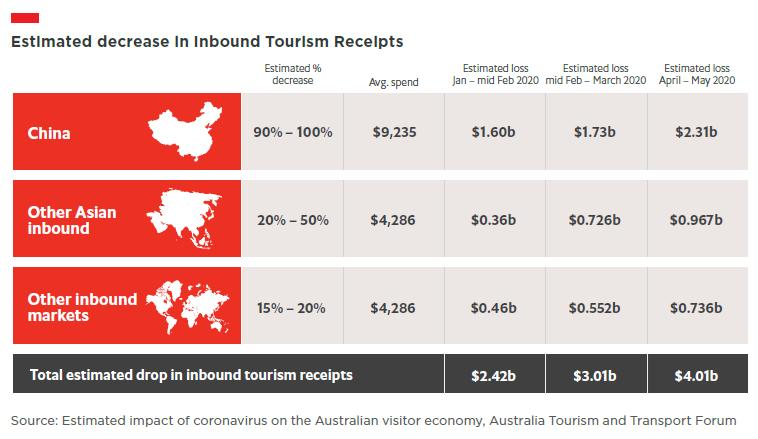Point out several critical features in this image. The estimated percentage decrease in inbound tourism receipts in China due to the impact of coronavirus is expected to be between 90% and 100%. Inbound tourism from other Asian markets has an average spend of $4,286 per person. The estimated loss in inbound tourism receipts during April-May 2020 due to the impact of coronavirus is estimated to be $4.01 billion. The impact of the COVID-19 pandemic on inbound tourism receipts is expected to cause a significant decrease in other inbound markets, ranging from 15% to 20%. The average spend made by inbound tourists from other inbound markets is $4,286. 